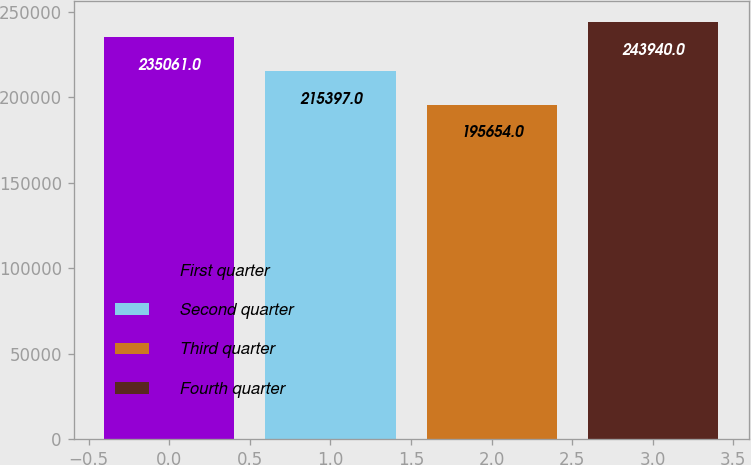<chart> <loc_0><loc_0><loc_500><loc_500><bar_chart><fcel>First quarter<fcel>Second quarter<fcel>Third quarter<fcel>Fourth quarter<nl><fcel>235061<fcel>215397<fcel>195654<fcel>243940<nl></chart> 